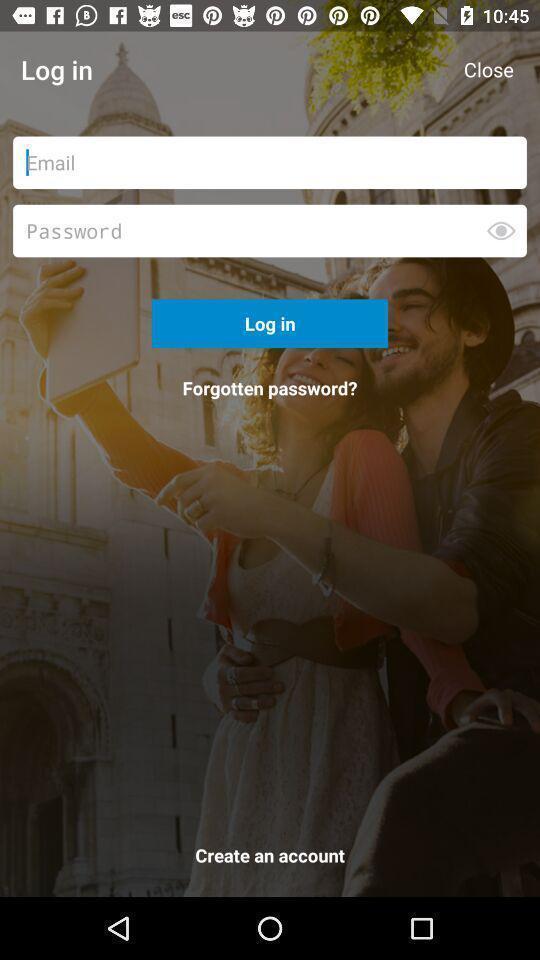What is the overall content of this screenshot? Login page. 